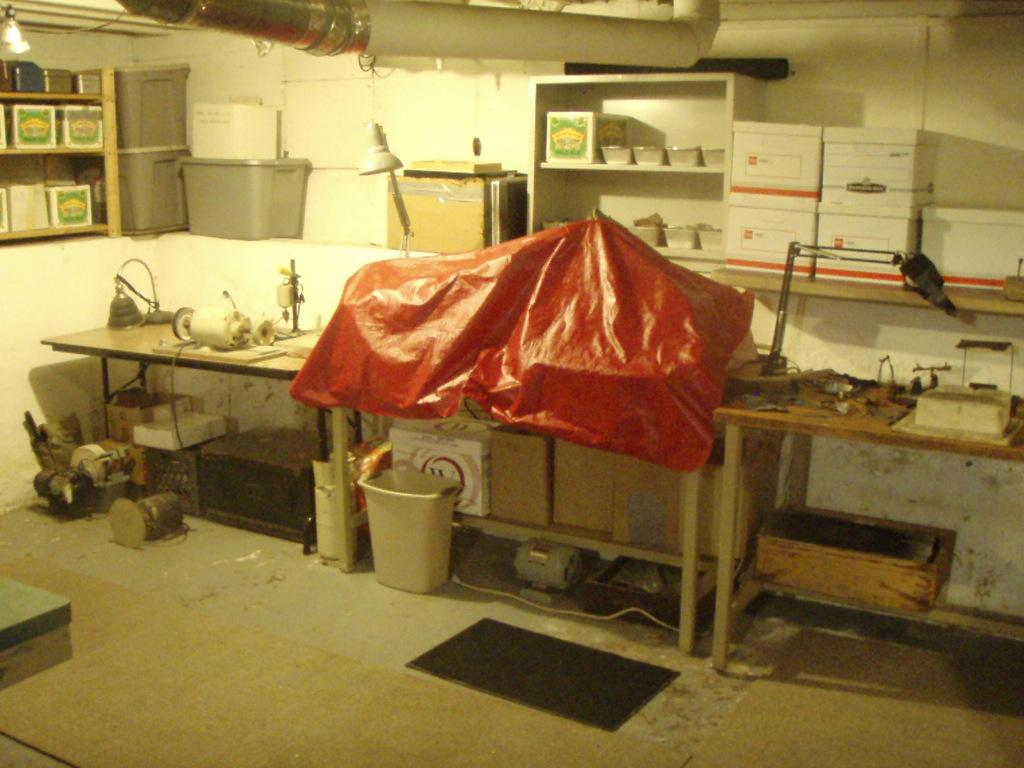What is on the table in the image? There are objects on the table. What is located under the table? There are cardboard boxes and a bin under the table. Can you describe the contents under the table? There are things under the table, including cardboard boxes and a bin. What can be seen in the racks in the image? There are boxes and objects in the racks. What type of containers are visible in the image? There are containers visible in the image. What is the source of light in the image? There is a lamp in the image. Can you see a robin flying in the image? There is no robin or flight activity present in the image. What type of plant is growing under the table? There is no plant visible in the image; the focus is on the cardboard boxes, bin, and other objects. 